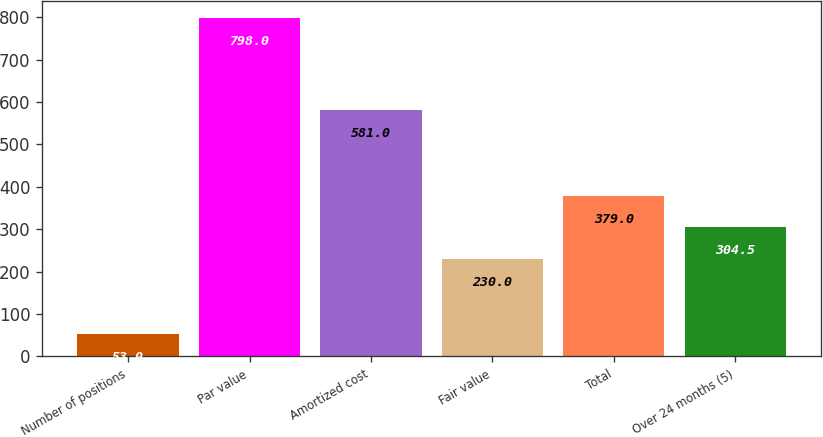Convert chart to OTSL. <chart><loc_0><loc_0><loc_500><loc_500><bar_chart><fcel>Number of positions<fcel>Par value<fcel>Amortized cost<fcel>Fair value<fcel>Total<fcel>Over 24 months (5)<nl><fcel>53<fcel>798<fcel>581<fcel>230<fcel>379<fcel>304.5<nl></chart> 